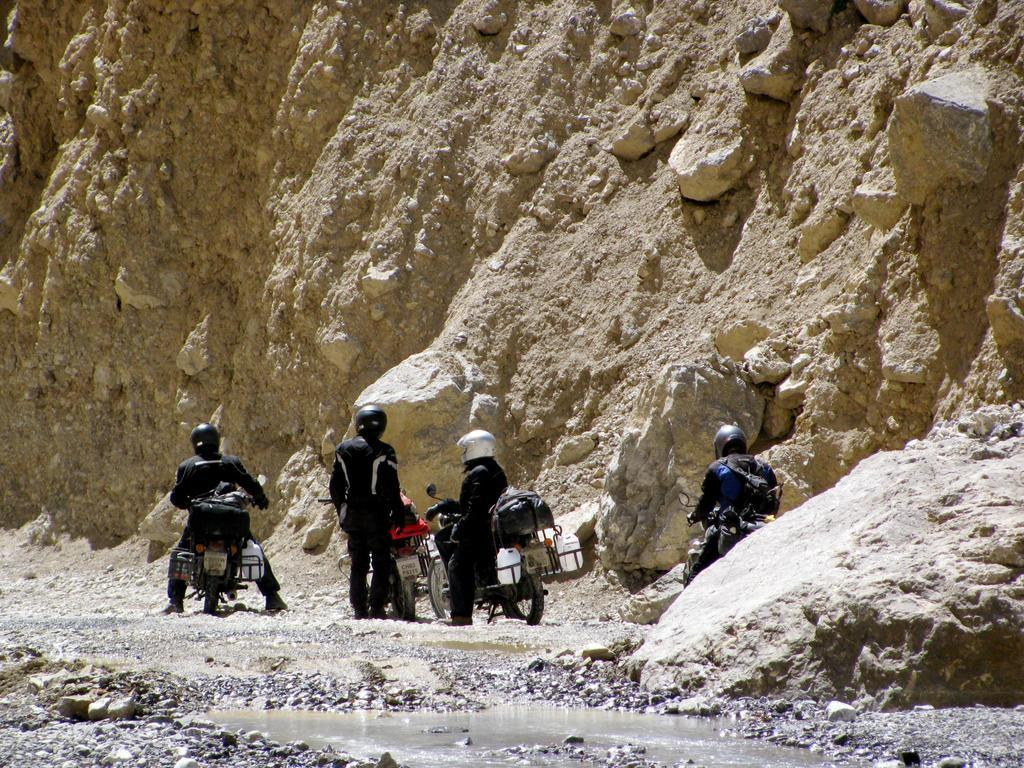Who or what is present in the image? There are people in the image. What are the people doing in the image? The people are on bikes. Can you describe the setting of the image? The image appears to depict an outcrop area. What type of playground equipment can be seen in the image? There is no playground equipment present in the image; it features people on bikes in an outcrop area. What is the yam doing in the image? There is no yam present in the image. 